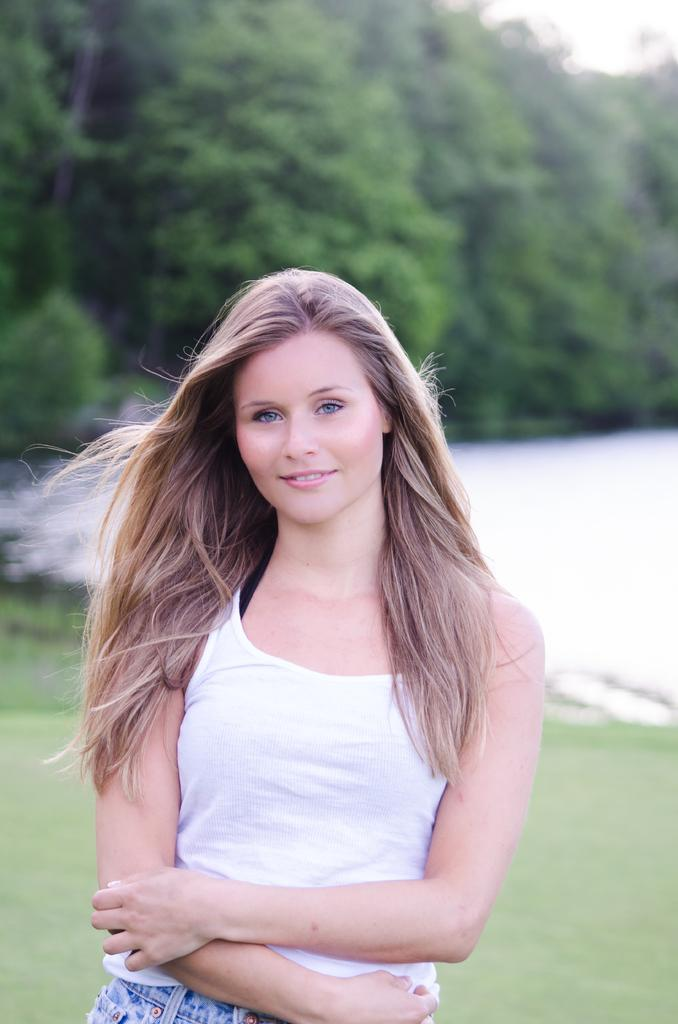Who is present in the image? There is a woman in the image. What is the woman doing in the image? The woman is standing and watching something. What is the woman's facial expression in the image? The woman is smiling in the image. What can be seen in the background of the image? The background of the image is blurred, but there are trees and grass visible. What type of quartz can be seen in the woman's hand in the image? There is no quartz present in the image; the woman is not holding anything. How many mittens can be seen on the woman's feet in the image? The woman is not wearing any mittens in the image, as mittens are typically worn on hands, not feet. 